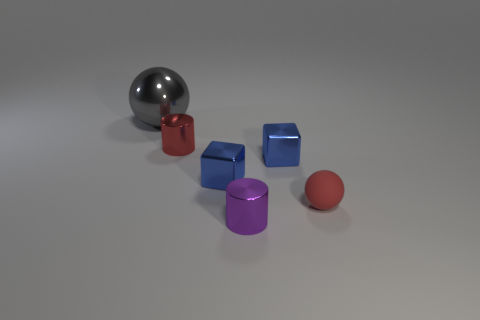Subtract all yellow balls. Subtract all cyan blocks. How many balls are left? 2 Add 2 tiny blue metal things. How many objects exist? 8 Subtract all cubes. How many objects are left? 4 Subtract all small red metallic things. Subtract all blocks. How many objects are left? 3 Add 4 rubber spheres. How many rubber spheres are left? 5 Add 4 blue metallic cylinders. How many blue metallic cylinders exist? 4 Subtract 0 cyan balls. How many objects are left? 6 